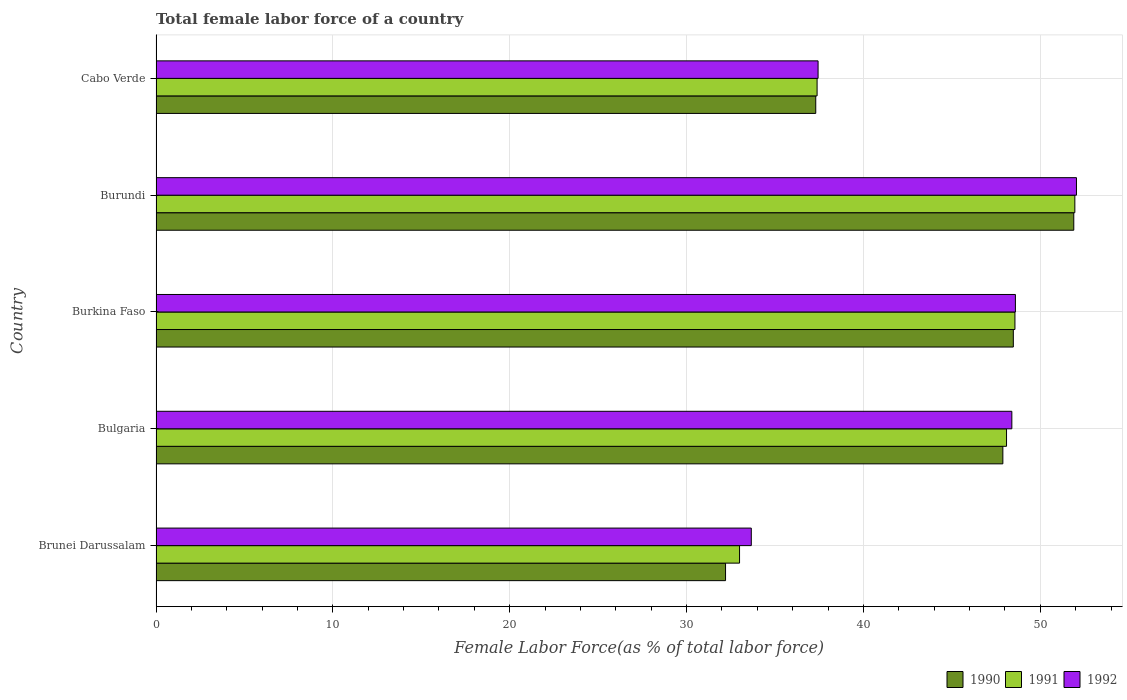How many groups of bars are there?
Keep it short and to the point. 5. Are the number of bars per tick equal to the number of legend labels?
Offer a very short reply. Yes. Are the number of bars on each tick of the Y-axis equal?
Your answer should be compact. Yes. How many bars are there on the 1st tick from the bottom?
Ensure brevity in your answer.  3. What is the label of the 2nd group of bars from the top?
Your response must be concise. Burundi. What is the percentage of female labor force in 1991 in Brunei Darussalam?
Your answer should be very brief. 33. Across all countries, what is the maximum percentage of female labor force in 1992?
Make the answer very short. 52.05. Across all countries, what is the minimum percentage of female labor force in 1991?
Provide a succinct answer. 33. In which country was the percentage of female labor force in 1992 maximum?
Give a very brief answer. Burundi. In which country was the percentage of female labor force in 1990 minimum?
Offer a very short reply. Brunei Darussalam. What is the total percentage of female labor force in 1991 in the graph?
Provide a succinct answer. 218.99. What is the difference between the percentage of female labor force in 1992 in Brunei Darussalam and that in Burundi?
Give a very brief answer. -18.39. What is the difference between the percentage of female labor force in 1992 in Burundi and the percentage of female labor force in 1990 in Cabo Verde?
Your response must be concise. 14.74. What is the average percentage of female labor force in 1992 per country?
Offer a very short reply. 44.03. What is the difference between the percentage of female labor force in 1992 and percentage of female labor force in 1991 in Burundi?
Provide a succinct answer. 0.09. In how many countries, is the percentage of female labor force in 1990 greater than 48 %?
Your answer should be very brief. 2. What is the ratio of the percentage of female labor force in 1990 in Brunei Darussalam to that in Bulgaria?
Make the answer very short. 0.67. Is the percentage of female labor force in 1992 in Burkina Faso less than that in Cabo Verde?
Your answer should be compact. No. What is the difference between the highest and the second highest percentage of female labor force in 1992?
Your answer should be compact. 3.45. What is the difference between the highest and the lowest percentage of female labor force in 1991?
Provide a succinct answer. 18.96. In how many countries, is the percentage of female labor force in 1990 greater than the average percentage of female labor force in 1990 taken over all countries?
Make the answer very short. 3. Is the sum of the percentage of female labor force in 1990 in Bulgaria and Burundi greater than the maximum percentage of female labor force in 1992 across all countries?
Offer a terse response. Yes. What does the 2nd bar from the bottom in Burundi represents?
Your response must be concise. 1991. Is it the case that in every country, the sum of the percentage of female labor force in 1992 and percentage of female labor force in 1990 is greater than the percentage of female labor force in 1991?
Your answer should be very brief. Yes. How many countries are there in the graph?
Give a very brief answer. 5. What is the difference between two consecutive major ticks on the X-axis?
Provide a succinct answer. 10. Are the values on the major ticks of X-axis written in scientific E-notation?
Your answer should be compact. No. Does the graph contain grids?
Give a very brief answer. Yes. Where does the legend appear in the graph?
Keep it short and to the point. Bottom right. How many legend labels are there?
Offer a very short reply. 3. What is the title of the graph?
Make the answer very short. Total female labor force of a country. What is the label or title of the X-axis?
Make the answer very short. Female Labor Force(as % of total labor force). What is the label or title of the Y-axis?
Your answer should be very brief. Country. What is the Female Labor Force(as % of total labor force) of 1990 in Brunei Darussalam?
Provide a short and direct response. 32.2. What is the Female Labor Force(as % of total labor force) in 1991 in Brunei Darussalam?
Offer a terse response. 33. What is the Female Labor Force(as % of total labor force) of 1992 in Brunei Darussalam?
Ensure brevity in your answer.  33.66. What is the Female Labor Force(as % of total labor force) in 1990 in Bulgaria?
Ensure brevity in your answer.  47.88. What is the Female Labor Force(as % of total labor force) in 1991 in Bulgaria?
Provide a short and direct response. 48.09. What is the Female Labor Force(as % of total labor force) of 1992 in Bulgaria?
Offer a terse response. 48.39. What is the Female Labor Force(as % of total labor force) in 1990 in Burkina Faso?
Offer a very short reply. 48.48. What is the Female Labor Force(as % of total labor force) in 1991 in Burkina Faso?
Your answer should be compact. 48.57. What is the Female Labor Force(as % of total labor force) in 1992 in Burkina Faso?
Your answer should be very brief. 48.59. What is the Female Labor Force(as % of total labor force) in 1990 in Burundi?
Your answer should be compact. 51.89. What is the Female Labor Force(as % of total labor force) of 1991 in Burundi?
Offer a terse response. 51.96. What is the Female Labor Force(as % of total labor force) of 1992 in Burundi?
Your answer should be compact. 52.05. What is the Female Labor Force(as % of total labor force) in 1990 in Cabo Verde?
Your response must be concise. 37.3. What is the Female Labor Force(as % of total labor force) in 1991 in Cabo Verde?
Provide a succinct answer. 37.38. What is the Female Labor Force(as % of total labor force) of 1992 in Cabo Verde?
Provide a succinct answer. 37.44. Across all countries, what is the maximum Female Labor Force(as % of total labor force) of 1990?
Your response must be concise. 51.89. Across all countries, what is the maximum Female Labor Force(as % of total labor force) of 1991?
Your answer should be very brief. 51.96. Across all countries, what is the maximum Female Labor Force(as % of total labor force) of 1992?
Make the answer very short. 52.05. Across all countries, what is the minimum Female Labor Force(as % of total labor force) of 1990?
Give a very brief answer. 32.2. Across all countries, what is the minimum Female Labor Force(as % of total labor force) of 1991?
Give a very brief answer. 33. Across all countries, what is the minimum Female Labor Force(as % of total labor force) of 1992?
Keep it short and to the point. 33.66. What is the total Female Labor Force(as % of total labor force) of 1990 in the graph?
Your answer should be compact. 217.76. What is the total Female Labor Force(as % of total labor force) of 1991 in the graph?
Your answer should be compact. 218.99. What is the total Female Labor Force(as % of total labor force) of 1992 in the graph?
Give a very brief answer. 220.13. What is the difference between the Female Labor Force(as % of total labor force) in 1990 in Brunei Darussalam and that in Bulgaria?
Your response must be concise. -15.68. What is the difference between the Female Labor Force(as % of total labor force) in 1991 in Brunei Darussalam and that in Bulgaria?
Provide a succinct answer. -15.1. What is the difference between the Female Labor Force(as % of total labor force) in 1992 in Brunei Darussalam and that in Bulgaria?
Ensure brevity in your answer.  -14.73. What is the difference between the Female Labor Force(as % of total labor force) in 1990 in Brunei Darussalam and that in Burkina Faso?
Offer a very short reply. -16.27. What is the difference between the Female Labor Force(as % of total labor force) of 1991 in Brunei Darussalam and that in Burkina Faso?
Offer a very short reply. -15.57. What is the difference between the Female Labor Force(as % of total labor force) of 1992 in Brunei Darussalam and that in Burkina Faso?
Give a very brief answer. -14.93. What is the difference between the Female Labor Force(as % of total labor force) in 1990 in Brunei Darussalam and that in Burundi?
Ensure brevity in your answer.  -19.69. What is the difference between the Female Labor Force(as % of total labor force) of 1991 in Brunei Darussalam and that in Burundi?
Ensure brevity in your answer.  -18.96. What is the difference between the Female Labor Force(as % of total labor force) in 1992 in Brunei Darussalam and that in Burundi?
Your answer should be very brief. -18.39. What is the difference between the Female Labor Force(as % of total labor force) in 1990 in Brunei Darussalam and that in Cabo Verde?
Offer a terse response. -5.1. What is the difference between the Female Labor Force(as % of total labor force) in 1991 in Brunei Darussalam and that in Cabo Verde?
Your answer should be very brief. -4.38. What is the difference between the Female Labor Force(as % of total labor force) in 1992 in Brunei Darussalam and that in Cabo Verde?
Provide a short and direct response. -3.78. What is the difference between the Female Labor Force(as % of total labor force) in 1990 in Bulgaria and that in Burkina Faso?
Give a very brief answer. -0.59. What is the difference between the Female Labor Force(as % of total labor force) in 1991 in Bulgaria and that in Burkina Faso?
Ensure brevity in your answer.  -0.48. What is the difference between the Female Labor Force(as % of total labor force) of 1992 in Bulgaria and that in Burkina Faso?
Offer a terse response. -0.2. What is the difference between the Female Labor Force(as % of total labor force) of 1990 in Bulgaria and that in Burundi?
Offer a terse response. -4.01. What is the difference between the Female Labor Force(as % of total labor force) of 1991 in Bulgaria and that in Burundi?
Ensure brevity in your answer.  -3.86. What is the difference between the Female Labor Force(as % of total labor force) in 1992 in Bulgaria and that in Burundi?
Keep it short and to the point. -3.65. What is the difference between the Female Labor Force(as % of total labor force) in 1990 in Bulgaria and that in Cabo Verde?
Provide a succinct answer. 10.58. What is the difference between the Female Labor Force(as % of total labor force) in 1991 in Bulgaria and that in Cabo Verde?
Offer a terse response. 10.71. What is the difference between the Female Labor Force(as % of total labor force) in 1992 in Bulgaria and that in Cabo Verde?
Your response must be concise. 10.96. What is the difference between the Female Labor Force(as % of total labor force) in 1990 in Burkina Faso and that in Burundi?
Provide a succinct answer. -3.42. What is the difference between the Female Labor Force(as % of total labor force) in 1991 in Burkina Faso and that in Burundi?
Provide a succinct answer. -3.39. What is the difference between the Female Labor Force(as % of total labor force) in 1992 in Burkina Faso and that in Burundi?
Make the answer very short. -3.45. What is the difference between the Female Labor Force(as % of total labor force) of 1990 in Burkina Faso and that in Cabo Verde?
Make the answer very short. 11.17. What is the difference between the Female Labor Force(as % of total labor force) in 1991 in Burkina Faso and that in Cabo Verde?
Your answer should be compact. 11.19. What is the difference between the Female Labor Force(as % of total labor force) of 1992 in Burkina Faso and that in Cabo Verde?
Ensure brevity in your answer.  11.16. What is the difference between the Female Labor Force(as % of total labor force) in 1990 in Burundi and that in Cabo Verde?
Keep it short and to the point. 14.59. What is the difference between the Female Labor Force(as % of total labor force) in 1991 in Burundi and that in Cabo Verde?
Give a very brief answer. 14.57. What is the difference between the Female Labor Force(as % of total labor force) in 1992 in Burundi and that in Cabo Verde?
Offer a very short reply. 14.61. What is the difference between the Female Labor Force(as % of total labor force) in 1990 in Brunei Darussalam and the Female Labor Force(as % of total labor force) in 1991 in Bulgaria?
Offer a very short reply. -15.89. What is the difference between the Female Labor Force(as % of total labor force) in 1990 in Brunei Darussalam and the Female Labor Force(as % of total labor force) in 1992 in Bulgaria?
Provide a succinct answer. -16.19. What is the difference between the Female Labor Force(as % of total labor force) of 1991 in Brunei Darussalam and the Female Labor Force(as % of total labor force) of 1992 in Bulgaria?
Provide a succinct answer. -15.4. What is the difference between the Female Labor Force(as % of total labor force) of 1990 in Brunei Darussalam and the Female Labor Force(as % of total labor force) of 1991 in Burkina Faso?
Ensure brevity in your answer.  -16.36. What is the difference between the Female Labor Force(as % of total labor force) of 1990 in Brunei Darussalam and the Female Labor Force(as % of total labor force) of 1992 in Burkina Faso?
Your answer should be compact. -16.39. What is the difference between the Female Labor Force(as % of total labor force) of 1991 in Brunei Darussalam and the Female Labor Force(as % of total labor force) of 1992 in Burkina Faso?
Offer a terse response. -15.6. What is the difference between the Female Labor Force(as % of total labor force) in 1990 in Brunei Darussalam and the Female Labor Force(as % of total labor force) in 1991 in Burundi?
Ensure brevity in your answer.  -19.75. What is the difference between the Female Labor Force(as % of total labor force) of 1990 in Brunei Darussalam and the Female Labor Force(as % of total labor force) of 1992 in Burundi?
Provide a short and direct response. -19.84. What is the difference between the Female Labor Force(as % of total labor force) of 1991 in Brunei Darussalam and the Female Labor Force(as % of total labor force) of 1992 in Burundi?
Offer a very short reply. -19.05. What is the difference between the Female Labor Force(as % of total labor force) of 1990 in Brunei Darussalam and the Female Labor Force(as % of total labor force) of 1991 in Cabo Verde?
Your answer should be very brief. -5.18. What is the difference between the Female Labor Force(as % of total labor force) in 1990 in Brunei Darussalam and the Female Labor Force(as % of total labor force) in 1992 in Cabo Verde?
Provide a short and direct response. -5.23. What is the difference between the Female Labor Force(as % of total labor force) in 1991 in Brunei Darussalam and the Female Labor Force(as % of total labor force) in 1992 in Cabo Verde?
Offer a terse response. -4.44. What is the difference between the Female Labor Force(as % of total labor force) in 1990 in Bulgaria and the Female Labor Force(as % of total labor force) in 1991 in Burkina Faso?
Offer a very short reply. -0.68. What is the difference between the Female Labor Force(as % of total labor force) of 1990 in Bulgaria and the Female Labor Force(as % of total labor force) of 1992 in Burkina Faso?
Offer a very short reply. -0.71. What is the difference between the Female Labor Force(as % of total labor force) of 1991 in Bulgaria and the Female Labor Force(as % of total labor force) of 1992 in Burkina Faso?
Your response must be concise. -0.5. What is the difference between the Female Labor Force(as % of total labor force) of 1990 in Bulgaria and the Female Labor Force(as % of total labor force) of 1991 in Burundi?
Your answer should be very brief. -4.07. What is the difference between the Female Labor Force(as % of total labor force) of 1990 in Bulgaria and the Female Labor Force(as % of total labor force) of 1992 in Burundi?
Your answer should be compact. -4.16. What is the difference between the Female Labor Force(as % of total labor force) in 1991 in Bulgaria and the Female Labor Force(as % of total labor force) in 1992 in Burundi?
Your answer should be compact. -3.95. What is the difference between the Female Labor Force(as % of total labor force) in 1990 in Bulgaria and the Female Labor Force(as % of total labor force) in 1991 in Cabo Verde?
Provide a short and direct response. 10.5. What is the difference between the Female Labor Force(as % of total labor force) in 1990 in Bulgaria and the Female Labor Force(as % of total labor force) in 1992 in Cabo Verde?
Give a very brief answer. 10.45. What is the difference between the Female Labor Force(as % of total labor force) of 1991 in Bulgaria and the Female Labor Force(as % of total labor force) of 1992 in Cabo Verde?
Ensure brevity in your answer.  10.66. What is the difference between the Female Labor Force(as % of total labor force) in 1990 in Burkina Faso and the Female Labor Force(as % of total labor force) in 1991 in Burundi?
Your answer should be very brief. -3.48. What is the difference between the Female Labor Force(as % of total labor force) in 1990 in Burkina Faso and the Female Labor Force(as % of total labor force) in 1992 in Burundi?
Provide a short and direct response. -3.57. What is the difference between the Female Labor Force(as % of total labor force) of 1991 in Burkina Faso and the Female Labor Force(as % of total labor force) of 1992 in Burundi?
Your answer should be very brief. -3.48. What is the difference between the Female Labor Force(as % of total labor force) in 1990 in Burkina Faso and the Female Labor Force(as % of total labor force) in 1991 in Cabo Verde?
Ensure brevity in your answer.  11.1. What is the difference between the Female Labor Force(as % of total labor force) in 1990 in Burkina Faso and the Female Labor Force(as % of total labor force) in 1992 in Cabo Verde?
Ensure brevity in your answer.  11.04. What is the difference between the Female Labor Force(as % of total labor force) of 1991 in Burkina Faso and the Female Labor Force(as % of total labor force) of 1992 in Cabo Verde?
Give a very brief answer. 11.13. What is the difference between the Female Labor Force(as % of total labor force) in 1990 in Burundi and the Female Labor Force(as % of total labor force) in 1991 in Cabo Verde?
Offer a terse response. 14.51. What is the difference between the Female Labor Force(as % of total labor force) in 1990 in Burundi and the Female Labor Force(as % of total labor force) in 1992 in Cabo Verde?
Your answer should be very brief. 14.46. What is the difference between the Female Labor Force(as % of total labor force) of 1991 in Burundi and the Female Labor Force(as % of total labor force) of 1992 in Cabo Verde?
Your answer should be very brief. 14.52. What is the average Female Labor Force(as % of total labor force) in 1990 per country?
Your response must be concise. 43.55. What is the average Female Labor Force(as % of total labor force) of 1991 per country?
Give a very brief answer. 43.8. What is the average Female Labor Force(as % of total labor force) in 1992 per country?
Offer a terse response. 44.03. What is the difference between the Female Labor Force(as % of total labor force) in 1990 and Female Labor Force(as % of total labor force) in 1991 in Brunei Darussalam?
Offer a terse response. -0.79. What is the difference between the Female Labor Force(as % of total labor force) in 1990 and Female Labor Force(as % of total labor force) in 1992 in Brunei Darussalam?
Make the answer very short. -1.46. What is the difference between the Female Labor Force(as % of total labor force) of 1991 and Female Labor Force(as % of total labor force) of 1992 in Brunei Darussalam?
Ensure brevity in your answer.  -0.66. What is the difference between the Female Labor Force(as % of total labor force) of 1990 and Female Labor Force(as % of total labor force) of 1991 in Bulgaria?
Your answer should be compact. -0.21. What is the difference between the Female Labor Force(as % of total labor force) in 1990 and Female Labor Force(as % of total labor force) in 1992 in Bulgaria?
Make the answer very short. -0.51. What is the difference between the Female Labor Force(as % of total labor force) of 1991 and Female Labor Force(as % of total labor force) of 1992 in Bulgaria?
Keep it short and to the point. -0.3. What is the difference between the Female Labor Force(as % of total labor force) of 1990 and Female Labor Force(as % of total labor force) of 1991 in Burkina Faso?
Keep it short and to the point. -0.09. What is the difference between the Female Labor Force(as % of total labor force) in 1990 and Female Labor Force(as % of total labor force) in 1992 in Burkina Faso?
Keep it short and to the point. -0.12. What is the difference between the Female Labor Force(as % of total labor force) of 1991 and Female Labor Force(as % of total labor force) of 1992 in Burkina Faso?
Ensure brevity in your answer.  -0.03. What is the difference between the Female Labor Force(as % of total labor force) of 1990 and Female Labor Force(as % of total labor force) of 1991 in Burundi?
Your response must be concise. -0.06. What is the difference between the Female Labor Force(as % of total labor force) of 1990 and Female Labor Force(as % of total labor force) of 1992 in Burundi?
Your answer should be very brief. -0.15. What is the difference between the Female Labor Force(as % of total labor force) in 1991 and Female Labor Force(as % of total labor force) in 1992 in Burundi?
Offer a terse response. -0.09. What is the difference between the Female Labor Force(as % of total labor force) in 1990 and Female Labor Force(as % of total labor force) in 1991 in Cabo Verde?
Offer a terse response. -0.08. What is the difference between the Female Labor Force(as % of total labor force) of 1990 and Female Labor Force(as % of total labor force) of 1992 in Cabo Verde?
Offer a terse response. -0.13. What is the difference between the Female Labor Force(as % of total labor force) of 1991 and Female Labor Force(as % of total labor force) of 1992 in Cabo Verde?
Offer a terse response. -0.06. What is the ratio of the Female Labor Force(as % of total labor force) of 1990 in Brunei Darussalam to that in Bulgaria?
Give a very brief answer. 0.67. What is the ratio of the Female Labor Force(as % of total labor force) of 1991 in Brunei Darussalam to that in Bulgaria?
Provide a succinct answer. 0.69. What is the ratio of the Female Labor Force(as % of total labor force) in 1992 in Brunei Darussalam to that in Bulgaria?
Keep it short and to the point. 0.7. What is the ratio of the Female Labor Force(as % of total labor force) in 1990 in Brunei Darussalam to that in Burkina Faso?
Offer a very short reply. 0.66. What is the ratio of the Female Labor Force(as % of total labor force) of 1991 in Brunei Darussalam to that in Burkina Faso?
Give a very brief answer. 0.68. What is the ratio of the Female Labor Force(as % of total labor force) in 1992 in Brunei Darussalam to that in Burkina Faso?
Offer a terse response. 0.69. What is the ratio of the Female Labor Force(as % of total labor force) in 1990 in Brunei Darussalam to that in Burundi?
Offer a very short reply. 0.62. What is the ratio of the Female Labor Force(as % of total labor force) in 1991 in Brunei Darussalam to that in Burundi?
Your answer should be compact. 0.64. What is the ratio of the Female Labor Force(as % of total labor force) of 1992 in Brunei Darussalam to that in Burundi?
Provide a short and direct response. 0.65. What is the ratio of the Female Labor Force(as % of total labor force) in 1990 in Brunei Darussalam to that in Cabo Verde?
Your response must be concise. 0.86. What is the ratio of the Female Labor Force(as % of total labor force) in 1991 in Brunei Darussalam to that in Cabo Verde?
Provide a short and direct response. 0.88. What is the ratio of the Female Labor Force(as % of total labor force) in 1992 in Brunei Darussalam to that in Cabo Verde?
Your answer should be compact. 0.9. What is the ratio of the Female Labor Force(as % of total labor force) of 1991 in Bulgaria to that in Burkina Faso?
Ensure brevity in your answer.  0.99. What is the ratio of the Female Labor Force(as % of total labor force) of 1990 in Bulgaria to that in Burundi?
Your response must be concise. 0.92. What is the ratio of the Female Labor Force(as % of total labor force) in 1991 in Bulgaria to that in Burundi?
Ensure brevity in your answer.  0.93. What is the ratio of the Female Labor Force(as % of total labor force) in 1992 in Bulgaria to that in Burundi?
Make the answer very short. 0.93. What is the ratio of the Female Labor Force(as % of total labor force) in 1990 in Bulgaria to that in Cabo Verde?
Keep it short and to the point. 1.28. What is the ratio of the Female Labor Force(as % of total labor force) of 1991 in Bulgaria to that in Cabo Verde?
Offer a terse response. 1.29. What is the ratio of the Female Labor Force(as % of total labor force) in 1992 in Bulgaria to that in Cabo Verde?
Provide a short and direct response. 1.29. What is the ratio of the Female Labor Force(as % of total labor force) in 1990 in Burkina Faso to that in Burundi?
Your answer should be very brief. 0.93. What is the ratio of the Female Labor Force(as % of total labor force) in 1991 in Burkina Faso to that in Burundi?
Give a very brief answer. 0.93. What is the ratio of the Female Labor Force(as % of total labor force) of 1992 in Burkina Faso to that in Burundi?
Your answer should be compact. 0.93. What is the ratio of the Female Labor Force(as % of total labor force) of 1990 in Burkina Faso to that in Cabo Verde?
Keep it short and to the point. 1.3. What is the ratio of the Female Labor Force(as % of total labor force) of 1991 in Burkina Faso to that in Cabo Verde?
Give a very brief answer. 1.3. What is the ratio of the Female Labor Force(as % of total labor force) in 1992 in Burkina Faso to that in Cabo Verde?
Offer a terse response. 1.3. What is the ratio of the Female Labor Force(as % of total labor force) in 1990 in Burundi to that in Cabo Verde?
Give a very brief answer. 1.39. What is the ratio of the Female Labor Force(as % of total labor force) of 1991 in Burundi to that in Cabo Verde?
Provide a succinct answer. 1.39. What is the ratio of the Female Labor Force(as % of total labor force) in 1992 in Burundi to that in Cabo Verde?
Your response must be concise. 1.39. What is the difference between the highest and the second highest Female Labor Force(as % of total labor force) of 1990?
Ensure brevity in your answer.  3.42. What is the difference between the highest and the second highest Female Labor Force(as % of total labor force) in 1991?
Your answer should be compact. 3.39. What is the difference between the highest and the second highest Female Labor Force(as % of total labor force) in 1992?
Provide a short and direct response. 3.45. What is the difference between the highest and the lowest Female Labor Force(as % of total labor force) of 1990?
Keep it short and to the point. 19.69. What is the difference between the highest and the lowest Female Labor Force(as % of total labor force) in 1991?
Keep it short and to the point. 18.96. What is the difference between the highest and the lowest Female Labor Force(as % of total labor force) of 1992?
Give a very brief answer. 18.39. 